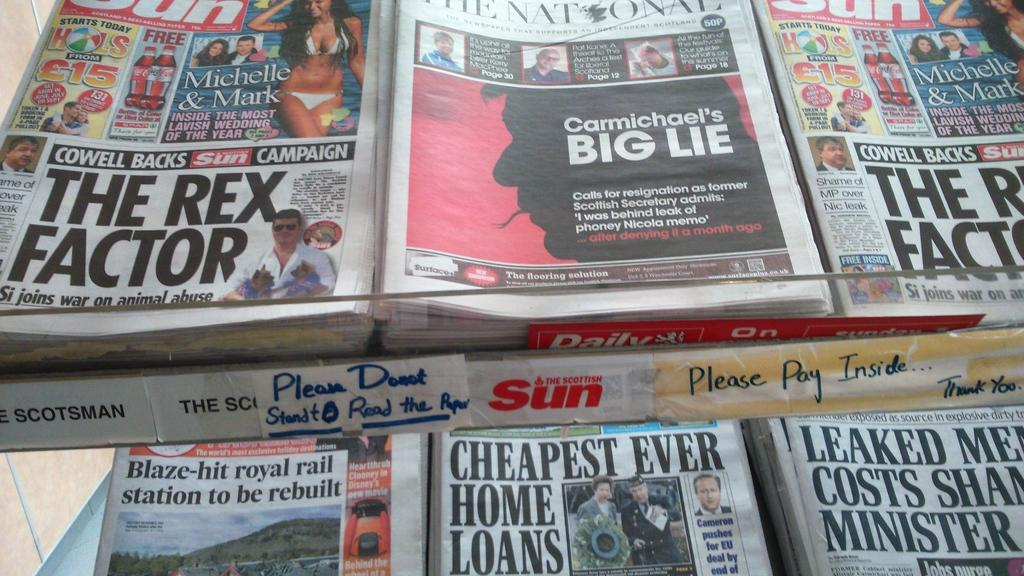<image>
Render a clear and concise summary of the photo. The Scottish Sun paper is stacked near other papers. 